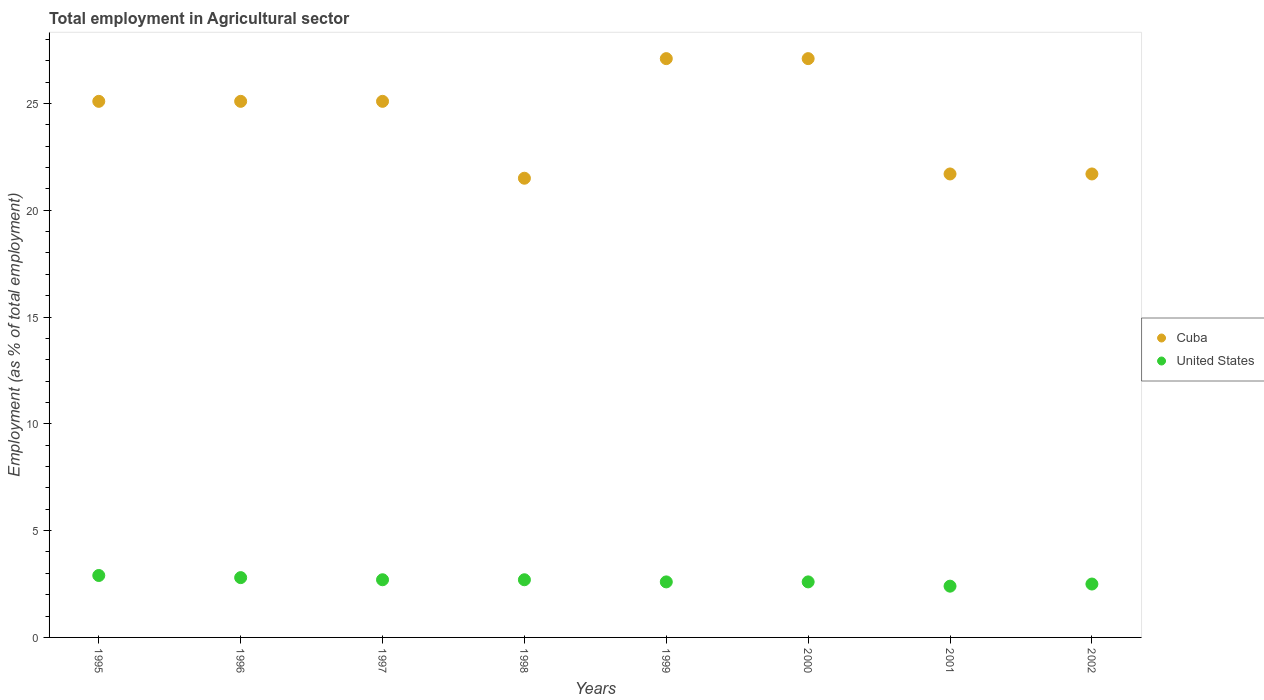How many different coloured dotlines are there?
Offer a terse response. 2. Is the number of dotlines equal to the number of legend labels?
Keep it short and to the point. Yes. What is the employment in agricultural sector in United States in 1995?
Offer a very short reply. 2.9. Across all years, what is the maximum employment in agricultural sector in United States?
Offer a terse response. 2.9. Across all years, what is the minimum employment in agricultural sector in United States?
Keep it short and to the point. 2.4. In which year was the employment in agricultural sector in Cuba maximum?
Make the answer very short. 1999. What is the total employment in agricultural sector in United States in the graph?
Ensure brevity in your answer.  21.2. What is the difference between the employment in agricultural sector in United States in 1997 and that in 1998?
Give a very brief answer. 0. What is the difference between the employment in agricultural sector in United States in 1995 and the employment in agricultural sector in Cuba in 2001?
Your answer should be very brief. -18.8. What is the average employment in agricultural sector in Cuba per year?
Provide a succinct answer. 24.3. In the year 1995, what is the difference between the employment in agricultural sector in Cuba and employment in agricultural sector in United States?
Offer a very short reply. 22.2. In how many years, is the employment in agricultural sector in United States greater than 23 %?
Your answer should be very brief. 0. What is the ratio of the employment in agricultural sector in Cuba in 1996 to that in 2001?
Keep it short and to the point. 1.16. Is the difference between the employment in agricultural sector in Cuba in 1997 and 2000 greater than the difference between the employment in agricultural sector in United States in 1997 and 2000?
Offer a terse response. No. What is the difference between the highest and the second highest employment in agricultural sector in United States?
Your answer should be very brief. 0.1. What is the difference between the highest and the lowest employment in agricultural sector in Cuba?
Offer a very short reply. 5.6. In how many years, is the employment in agricultural sector in United States greater than the average employment in agricultural sector in United States taken over all years?
Keep it short and to the point. 4. Does the employment in agricultural sector in United States monotonically increase over the years?
Offer a terse response. No. Is the employment in agricultural sector in United States strictly greater than the employment in agricultural sector in Cuba over the years?
Provide a short and direct response. No. Are the values on the major ticks of Y-axis written in scientific E-notation?
Make the answer very short. No. Does the graph contain any zero values?
Provide a succinct answer. No. Where does the legend appear in the graph?
Your answer should be compact. Center right. How are the legend labels stacked?
Your response must be concise. Vertical. What is the title of the graph?
Your answer should be very brief. Total employment in Agricultural sector. Does "Middle income" appear as one of the legend labels in the graph?
Offer a terse response. No. What is the label or title of the X-axis?
Make the answer very short. Years. What is the label or title of the Y-axis?
Your answer should be very brief. Employment (as % of total employment). What is the Employment (as % of total employment) of Cuba in 1995?
Your answer should be compact. 25.1. What is the Employment (as % of total employment) in United States in 1995?
Your answer should be compact. 2.9. What is the Employment (as % of total employment) in Cuba in 1996?
Provide a succinct answer. 25.1. What is the Employment (as % of total employment) of United States in 1996?
Offer a terse response. 2.8. What is the Employment (as % of total employment) in Cuba in 1997?
Offer a terse response. 25.1. What is the Employment (as % of total employment) of United States in 1997?
Make the answer very short. 2.7. What is the Employment (as % of total employment) of United States in 1998?
Your answer should be compact. 2.7. What is the Employment (as % of total employment) in Cuba in 1999?
Your response must be concise. 27.1. What is the Employment (as % of total employment) of United States in 1999?
Your answer should be compact. 2.6. What is the Employment (as % of total employment) in Cuba in 2000?
Your response must be concise. 27.1. What is the Employment (as % of total employment) in United States in 2000?
Your response must be concise. 2.6. What is the Employment (as % of total employment) in Cuba in 2001?
Your answer should be compact. 21.7. What is the Employment (as % of total employment) in United States in 2001?
Your response must be concise. 2.4. What is the Employment (as % of total employment) of Cuba in 2002?
Provide a short and direct response. 21.7. Across all years, what is the maximum Employment (as % of total employment) in Cuba?
Provide a succinct answer. 27.1. Across all years, what is the maximum Employment (as % of total employment) of United States?
Your answer should be compact. 2.9. Across all years, what is the minimum Employment (as % of total employment) in Cuba?
Your response must be concise. 21.5. Across all years, what is the minimum Employment (as % of total employment) in United States?
Your answer should be very brief. 2.4. What is the total Employment (as % of total employment) in Cuba in the graph?
Offer a very short reply. 194.4. What is the total Employment (as % of total employment) in United States in the graph?
Keep it short and to the point. 21.2. What is the difference between the Employment (as % of total employment) in Cuba in 1995 and that in 1996?
Provide a short and direct response. 0. What is the difference between the Employment (as % of total employment) of Cuba in 1995 and that in 1997?
Make the answer very short. 0. What is the difference between the Employment (as % of total employment) in United States in 1995 and that in 1997?
Your answer should be compact. 0.2. What is the difference between the Employment (as % of total employment) of Cuba in 1995 and that in 1998?
Provide a short and direct response. 3.6. What is the difference between the Employment (as % of total employment) in United States in 1995 and that in 1998?
Your answer should be very brief. 0.2. What is the difference between the Employment (as % of total employment) of United States in 1995 and that in 1999?
Make the answer very short. 0.3. What is the difference between the Employment (as % of total employment) of Cuba in 1995 and that in 2000?
Provide a succinct answer. -2. What is the difference between the Employment (as % of total employment) of Cuba in 1995 and that in 2001?
Offer a very short reply. 3.4. What is the difference between the Employment (as % of total employment) in Cuba in 1995 and that in 2002?
Offer a terse response. 3.4. What is the difference between the Employment (as % of total employment) of Cuba in 1996 and that in 1997?
Your answer should be very brief. 0. What is the difference between the Employment (as % of total employment) in Cuba in 1996 and that in 1998?
Offer a terse response. 3.6. What is the difference between the Employment (as % of total employment) of United States in 1996 and that in 1998?
Ensure brevity in your answer.  0.1. What is the difference between the Employment (as % of total employment) of United States in 1996 and that in 1999?
Provide a short and direct response. 0.2. What is the difference between the Employment (as % of total employment) in Cuba in 1996 and that in 2001?
Your response must be concise. 3.4. What is the difference between the Employment (as % of total employment) in Cuba in 1997 and that in 1998?
Provide a succinct answer. 3.6. What is the difference between the Employment (as % of total employment) in United States in 1997 and that in 1998?
Offer a very short reply. 0. What is the difference between the Employment (as % of total employment) of United States in 1997 and that in 1999?
Provide a succinct answer. 0.1. What is the difference between the Employment (as % of total employment) of Cuba in 1997 and that in 2001?
Offer a terse response. 3.4. What is the difference between the Employment (as % of total employment) of United States in 1997 and that in 2001?
Offer a terse response. 0.3. What is the difference between the Employment (as % of total employment) of Cuba in 1997 and that in 2002?
Give a very brief answer. 3.4. What is the difference between the Employment (as % of total employment) in United States in 1997 and that in 2002?
Offer a very short reply. 0.2. What is the difference between the Employment (as % of total employment) in Cuba in 1998 and that in 1999?
Your answer should be compact. -5.6. What is the difference between the Employment (as % of total employment) in Cuba in 1998 and that in 2000?
Your answer should be compact. -5.6. What is the difference between the Employment (as % of total employment) in United States in 1998 and that in 2000?
Offer a terse response. 0.1. What is the difference between the Employment (as % of total employment) in United States in 1998 and that in 2001?
Provide a succinct answer. 0.3. What is the difference between the Employment (as % of total employment) in Cuba in 2000 and that in 2002?
Give a very brief answer. 5.4. What is the difference between the Employment (as % of total employment) in United States in 2000 and that in 2002?
Your answer should be very brief. 0.1. What is the difference between the Employment (as % of total employment) of Cuba in 2001 and that in 2002?
Your response must be concise. 0. What is the difference between the Employment (as % of total employment) of Cuba in 1995 and the Employment (as % of total employment) of United States in 1996?
Provide a short and direct response. 22.3. What is the difference between the Employment (as % of total employment) of Cuba in 1995 and the Employment (as % of total employment) of United States in 1997?
Offer a terse response. 22.4. What is the difference between the Employment (as % of total employment) in Cuba in 1995 and the Employment (as % of total employment) in United States in 1998?
Your response must be concise. 22.4. What is the difference between the Employment (as % of total employment) in Cuba in 1995 and the Employment (as % of total employment) in United States in 2001?
Your answer should be compact. 22.7. What is the difference between the Employment (as % of total employment) of Cuba in 1995 and the Employment (as % of total employment) of United States in 2002?
Offer a very short reply. 22.6. What is the difference between the Employment (as % of total employment) of Cuba in 1996 and the Employment (as % of total employment) of United States in 1997?
Provide a short and direct response. 22.4. What is the difference between the Employment (as % of total employment) in Cuba in 1996 and the Employment (as % of total employment) in United States in 1998?
Give a very brief answer. 22.4. What is the difference between the Employment (as % of total employment) in Cuba in 1996 and the Employment (as % of total employment) in United States in 2000?
Your response must be concise. 22.5. What is the difference between the Employment (as % of total employment) in Cuba in 1996 and the Employment (as % of total employment) in United States in 2001?
Provide a succinct answer. 22.7. What is the difference between the Employment (as % of total employment) of Cuba in 1996 and the Employment (as % of total employment) of United States in 2002?
Your answer should be very brief. 22.6. What is the difference between the Employment (as % of total employment) of Cuba in 1997 and the Employment (as % of total employment) of United States in 1998?
Provide a succinct answer. 22.4. What is the difference between the Employment (as % of total employment) of Cuba in 1997 and the Employment (as % of total employment) of United States in 1999?
Offer a very short reply. 22.5. What is the difference between the Employment (as % of total employment) of Cuba in 1997 and the Employment (as % of total employment) of United States in 2001?
Your answer should be compact. 22.7. What is the difference between the Employment (as % of total employment) in Cuba in 1997 and the Employment (as % of total employment) in United States in 2002?
Your response must be concise. 22.6. What is the difference between the Employment (as % of total employment) in Cuba in 1999 and the Employment (as % of total employment) in United States in 2000?
Provide a short and direct response. 24.5. What is the difference between the Employment (as % of total employment) in Cuba in 1999 and the Employment (as % of total employment) in United States in 2001?
Provide a short and direct response. 24.7. What is the difference between the Employment (as % of total employment) of Cuba in 1999 and the Employment (as % of total employment) of United States in 2002?
Provide a short and direct response. 24.6. What is the difference between the Employment (as % of total employment) in Cuba in 2000 and the Employment (as % of total employment) in United States in 2001?
Your response must be concise. 24.7. What is the difference between the Employment (as % of total employment) in Cuba in 2000 and the Employment (as % of total employment) in United States in 2002?
Ensure brevity in your answer.  24.6. What is the average Employment (as % of total employment) of Cuba per year?
Give a very brief answer. 24.3. What is the average Employment (as % of total employment) in United States per year?
Your answer should be compact. 2.65. In the year 1996, what is the difference between the Employment (as % of total employment) in Cuba and Employment (as % of total employment) in United States?
Provide a short and direct response. 22.3. In the year 1997, what is the difference between the Employment (as % of total employment) of Cuba and Employment (as % of total employment) of United States?
Give a very brief answer. 22.4. In the year 1998, what is the difference between the Employment (as % of total employment) of Cuba and Employment (as % of total employment) of United States?
Ensure brevity in your answer.  18.8. In the year 2000, what is the difference between the Employment (as % of total employment) of Cuba and Employment (as % of total employment) of United States?
Your answer should be compact. 24.5. In the year 2001, what is the difference between the Employment (as % of total employment) of Cuba and Employment (as % of total employment) of United States?
Provide a short and direct response. 19.3. What is the ratio of the Employment (as % of total employment) in Cuba in 1995 to that in 1996?
Ensure brevity in your answer.  1. What is the ratio of the Employment (as % of total employment) in United States in 1995 to that in 1996?
Your response must be concise. 1.04. What is the ratio of the Employment (as % of total employment) in Cuba in 1995 to that in 1997?
Offer a terse response. 1. What is the ratio of the Employment (as % of total employment) of United States in 1995 to that in 1997?
Give a very brief answer. 1.07. What is the ratio of the Employment (as % of total employment) in Cuba in 1995 to that in 1998?
Make the answer very short. 1.17. What is the ratio of the Employment (as % of total employment) in United States in 1995 to that in 1998?
Make the answer very short. 1.07. What is the ratio of the Employment (as % of total employment) in Cuba in 1995 to that in 1999?
Offer a terse response. 0.93. What is the ratio of the Employment (as % of total employment) of United States in 1995 to that in 1999?
Your response must be concise. 1.12. What is the ratio of the Employment (as % of total employment) in Cuba in 1995 to that in 2000?
Make the answer very short. 0.93. What is the ratio of the Employment (as % of total employment) in United States in 1995 to that in 2000?
Ensure brevity in your answer.  1.12. What is the ratio of the Employment (as % of total employment) in Cuba in 1995 to that in 2001?
Your answer should be compact. 1.16. What is the ratio of the Employment (as % of total employment) in United States in 1995 to that in 2001?
Provide a succinct answer. 1.21. What is the ratio of the Employment (as % of total employment) of Cuba in 1995 to that in 2002?
Your answer should be very brief. 1.16. What is the ratio of the Employment (as % of total employment) in United States in 1995 to that in 2002?
Your answer should be very brief. 1.16. What is the ratio of the Employment (as % of total employment) in Cuba in 1996 to that in 1997?
Your response must be concise. 1. What is the ratio of the Employment (as % of total employment) in United States in 1996 to that in 1997?
Provide a succinct answer. 1.04. What is the ratio of the Employment (as % of total employment) of Cuba in 1996 to that in 1998?
Ensure brevity in your answer.  1.17. What is the ratio of the Employment (as % of total employment) in United States in 1996 to that in 1998?
Offer a terse response. 1.04. What is the ratio of the Employment (as % of total employment) in Cuba in 1996 to that in 1999?
Offer a terse response. 0.93. What is the ratio of the Employment (as % of total employment) of United States in 1996 to that in 1999?
Provide a succinct answer. 1.08. What is the ratio of the Employment (as % of total employment) of Cuba in 1996 to that in 2000?
Provide a short and direct response. 0.93. What is the ratio of the Employment (as % of total employment) of Cuba in 1996 to that in 2001?
Provide a succinct answer. 1.16. What is the ratio of the Employment (as % of total employment) in United States in 1996 to that in 2001?
Your answer should be very brief. 1.17. What is the ratio of the Employment (as % of total employment) in Cuba in 1996 to that in 2002?
Give a very brief answer. 1.16. What is the ratio of the Employment (as % of total employment) in United States in 1996 to that in 2002?
Offer a very short reply. 1.12. What is the ratio of the Employment (as % of total employment) in Cuba in 1997 to that in 1998?
Your answer should be very brief. 1.17. What is the ratio of the Employment (as % of total employment) of United States in 1997 to that in 1998?
Keep it short and to the point. 1. What is the ratio of the Employment (as % of total employment) of Cuba in 1997 to that in 1999?
Your answer should be very brief. 0.93. What is the ratio of the Employment (as % of total employment) in United States in 1997 to that in 1999?
Make the answer very short. 1.04. What is the ratio of the Employment (as % of total employment) in Cuba in 1997 to that in 2000?
Provide a succinct answer. 0.93. What is the ratio of the Employment (as % of total employment) in Cuba in 1997 to that in 2001?
Make the answer very short. 1.16. What is the ratio of the Employment (as % of total employment) of United States in 1997 to that in 2001?
Keep it short and to the point. 1.12. What is the ratio of the Employment (as % of total employment) in Cuba in 1997 to that in 2002?
Provide a short and direct response. 1.16. What is the ratio of the Employment (as % of total employment) of United States in 1997 to that in 2002?
Provide a succinct answer. 1.08. What is the ratio of the Employment (as % of total employment) of Cuba in 1998 to that in 1999?
Your answer should be compact. 0.79. What is the ratio of the Employment (as % of total employment) in Cuba in 1998 to that in 2000?
Offer a very short reply. 0.79. What is the ratio of the Employment (as % of total employment) of Cuba in 1998 to that in 2001?
Your answer should be compact. 0.99. What is the ratio of the Employment (as % of total employment) in Cuba in 1998 to that in 2002?
Keep it short and to the point. 0.99. What is the ratio of the Employment (as % of total employment) in United States in 1998 to that in 2002?
Your answer should be very brief. 1.08. What is the ratio of the Employment (as % of total employment) of Cuba in 1999 to that in 2000?
Your answer should be very brief. 1. What is the ratio of the Employment (as % of total employment) in United States in 1999 to that in 2000?
Give a very brief answer. 1. What is the ratio of the Employment (as % of total employment) in Cuba in 1999 to that in 2001?
Your answer should be compact. 1.25. What is the ratio of the Employment (as % of total employment) of Cuba in 1999 to that in 2002?
Provide a succinct answer. 1.25. What is the ratio of the Employment (as % of total employment) of United States in 1999 to that in 2002?
Make the answer very short. 1.04. What is the ratio of the Employment (as % of total employment) of Cuba in 2000 to that in 2001?
Your answer should be compact. 1.25. What is the ratio of the Employment (as % of total employment) of Cuba in 2000 to that in 2002?
Provide a succinct answer. 1.25. What is the ratio of the Employment (as % of total employment) in United States in 2000 to that in 2002?
Offer a terse response. 1.04. What is the ratio of the Employment (as % of total employment) of Cuba in 2001 to that in 2002?
Give a very brief answer. 1. What is the difference between the highest and the second highest Employment (as % of total employment) in Cuba?
Keep it short and to the point. 0. What is the difference between the highest and the lowest Employment (as % of total employment) of United States?
Your answer should be very brief. 0.5. 